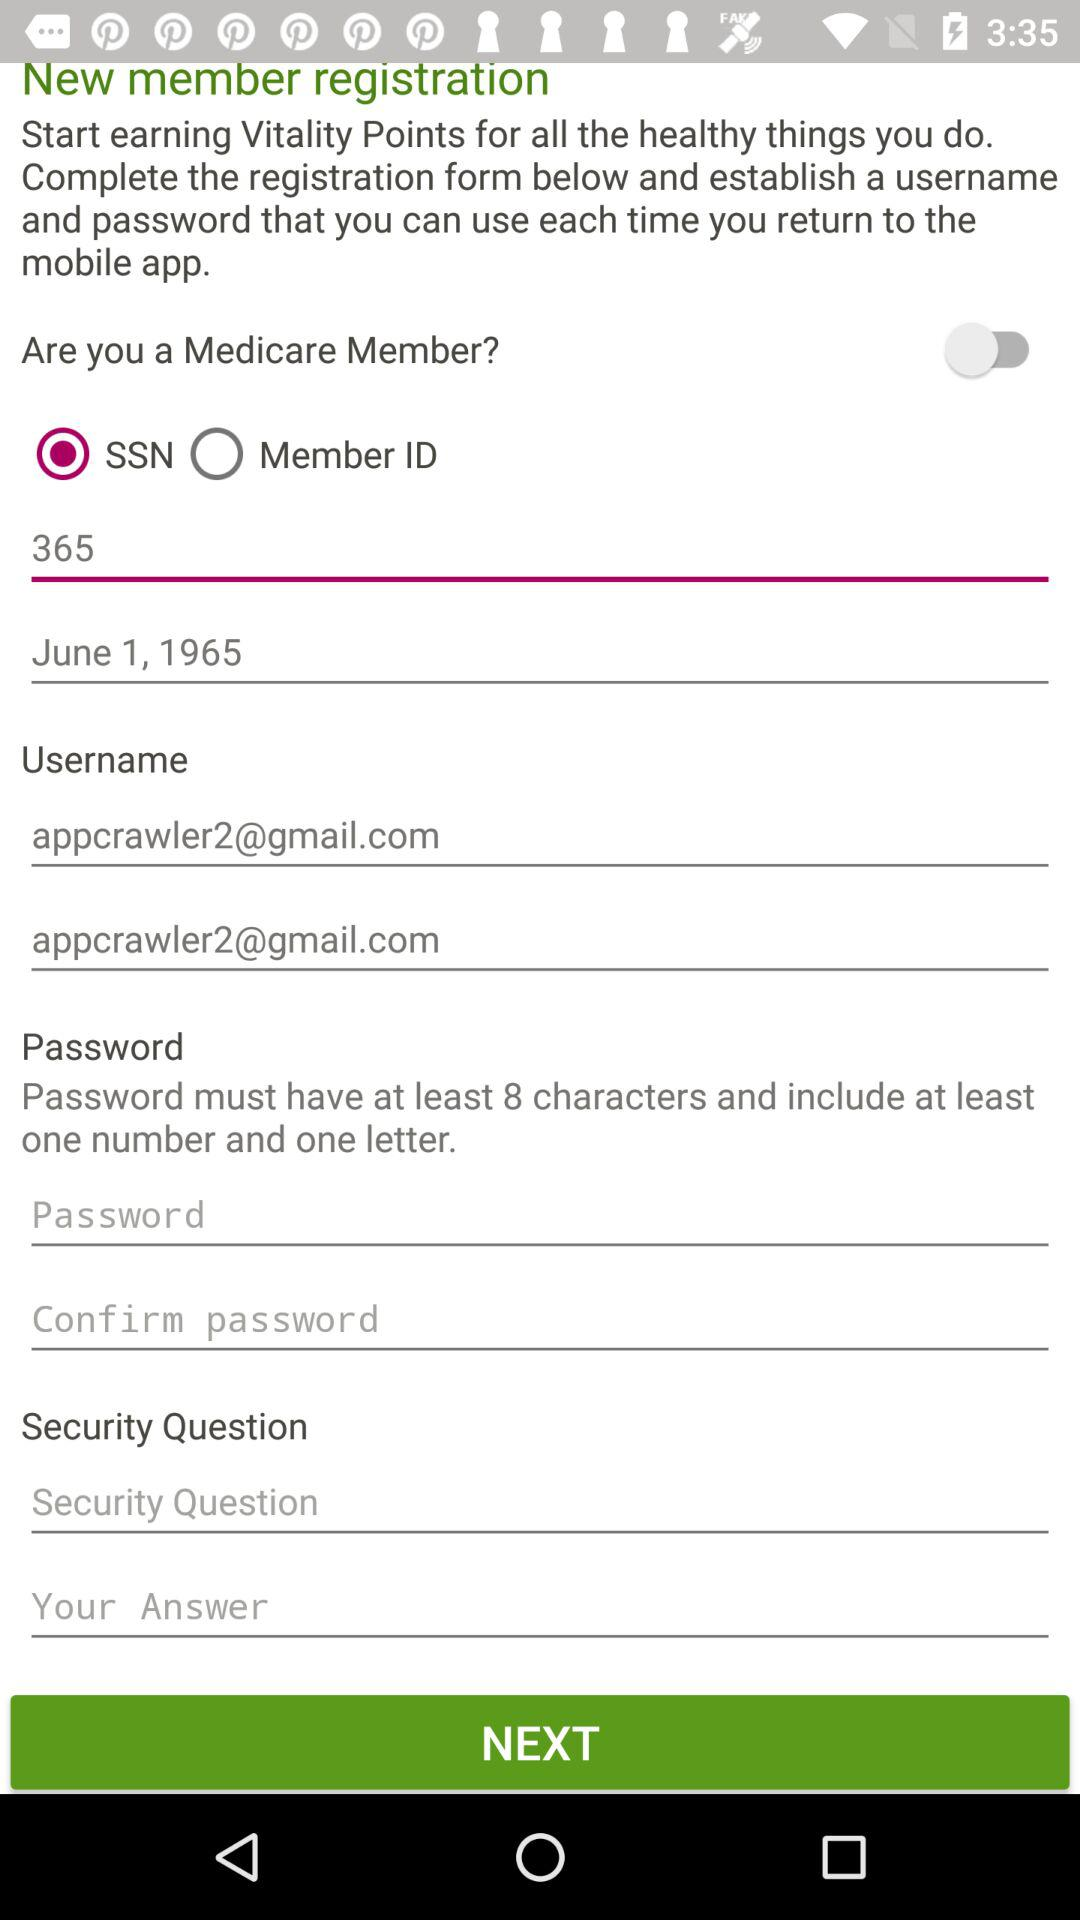What is the selected option for Medicare members? The selected option is "SSN". 